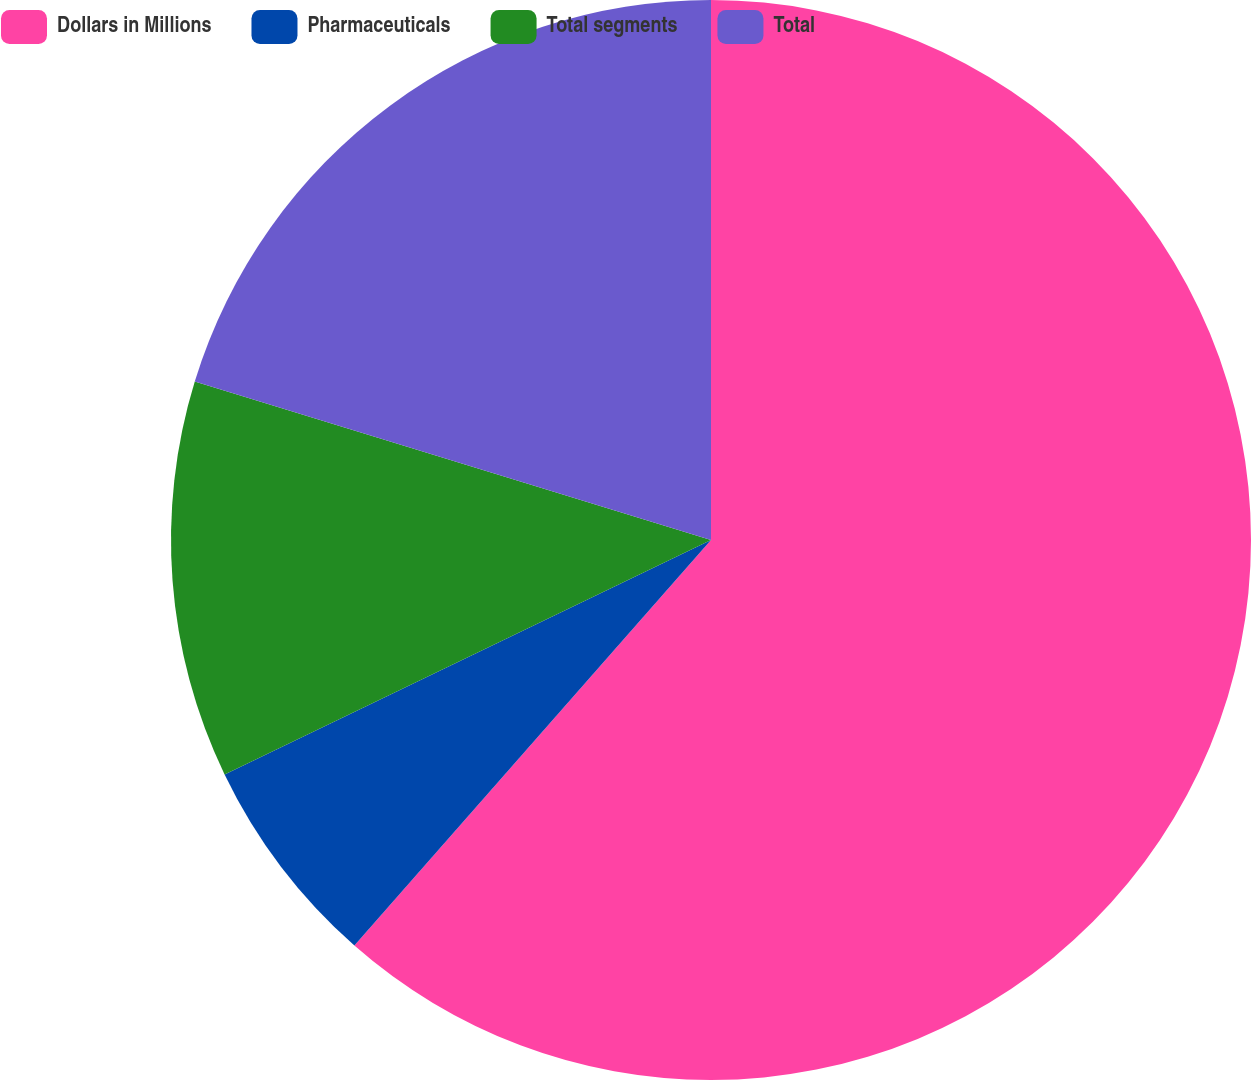Convert chart to OTSL. <chart><loc_0><loc_0><loc_500><loc_500><pie_chart><fcel>Dollars in Millions<fcel>Pharmaceuticals<fcel>Total segments<fcel>Total<nl><fcel>61.48%<fcel>6.37%<fcel>11.89%<fcel>20.26%<nl></chart> 